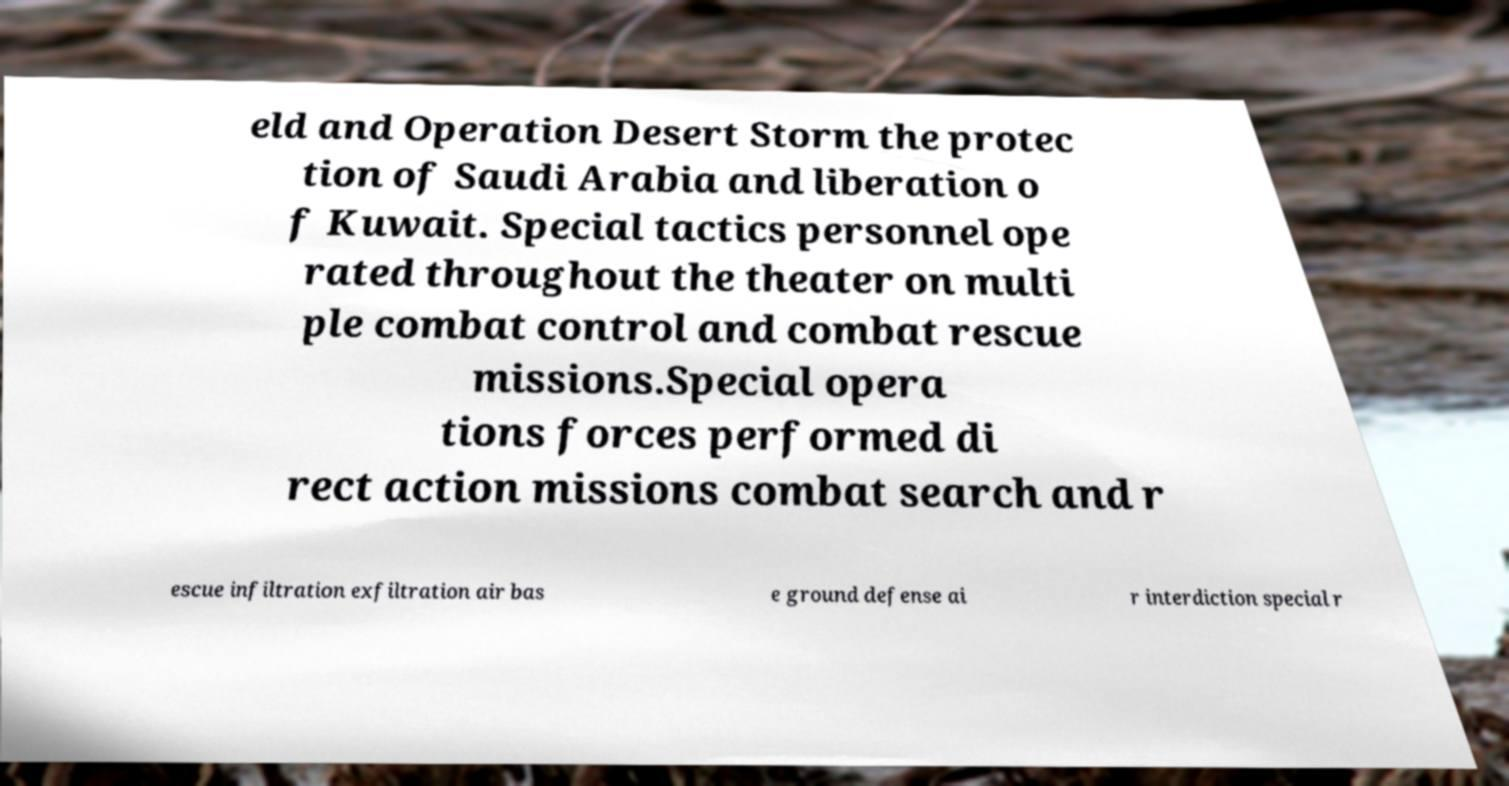Please read and relay the text visible in this image. What does it say? eld and Operation Desert Storm the protec tion of Saudi Arabia and liberation o f Kuwait. Special tactics personnel ope rated throughout the theater on multi ple combat control and combat rescue missions.Special opera tions forces performed di rect action missions combat search and r escue infiltration exfiltration air bas e ground defense ai r interdiction special r 